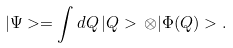Convert formula to latex. <formula><loc_0><loc_0><loc_500><loc_500>| \Psi > = \int d Q \, | Q > \, \otimes | \Phi ( Q ) > .</formula> 